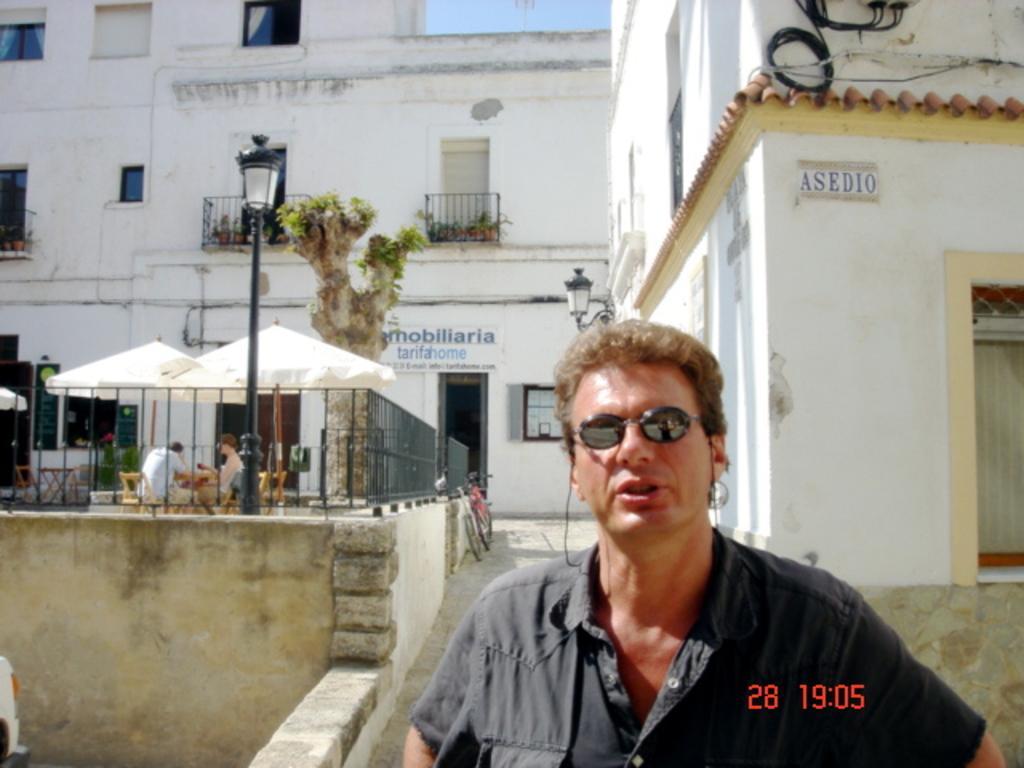Could you give a brief overview of what you see in this image? In this picture, we can see a few people, and we can see sheds, poles, lights, path, wall, and we can see buildings with windows, door, and some objects attached to it, we can see tree, plants, posters with text and the sky. 